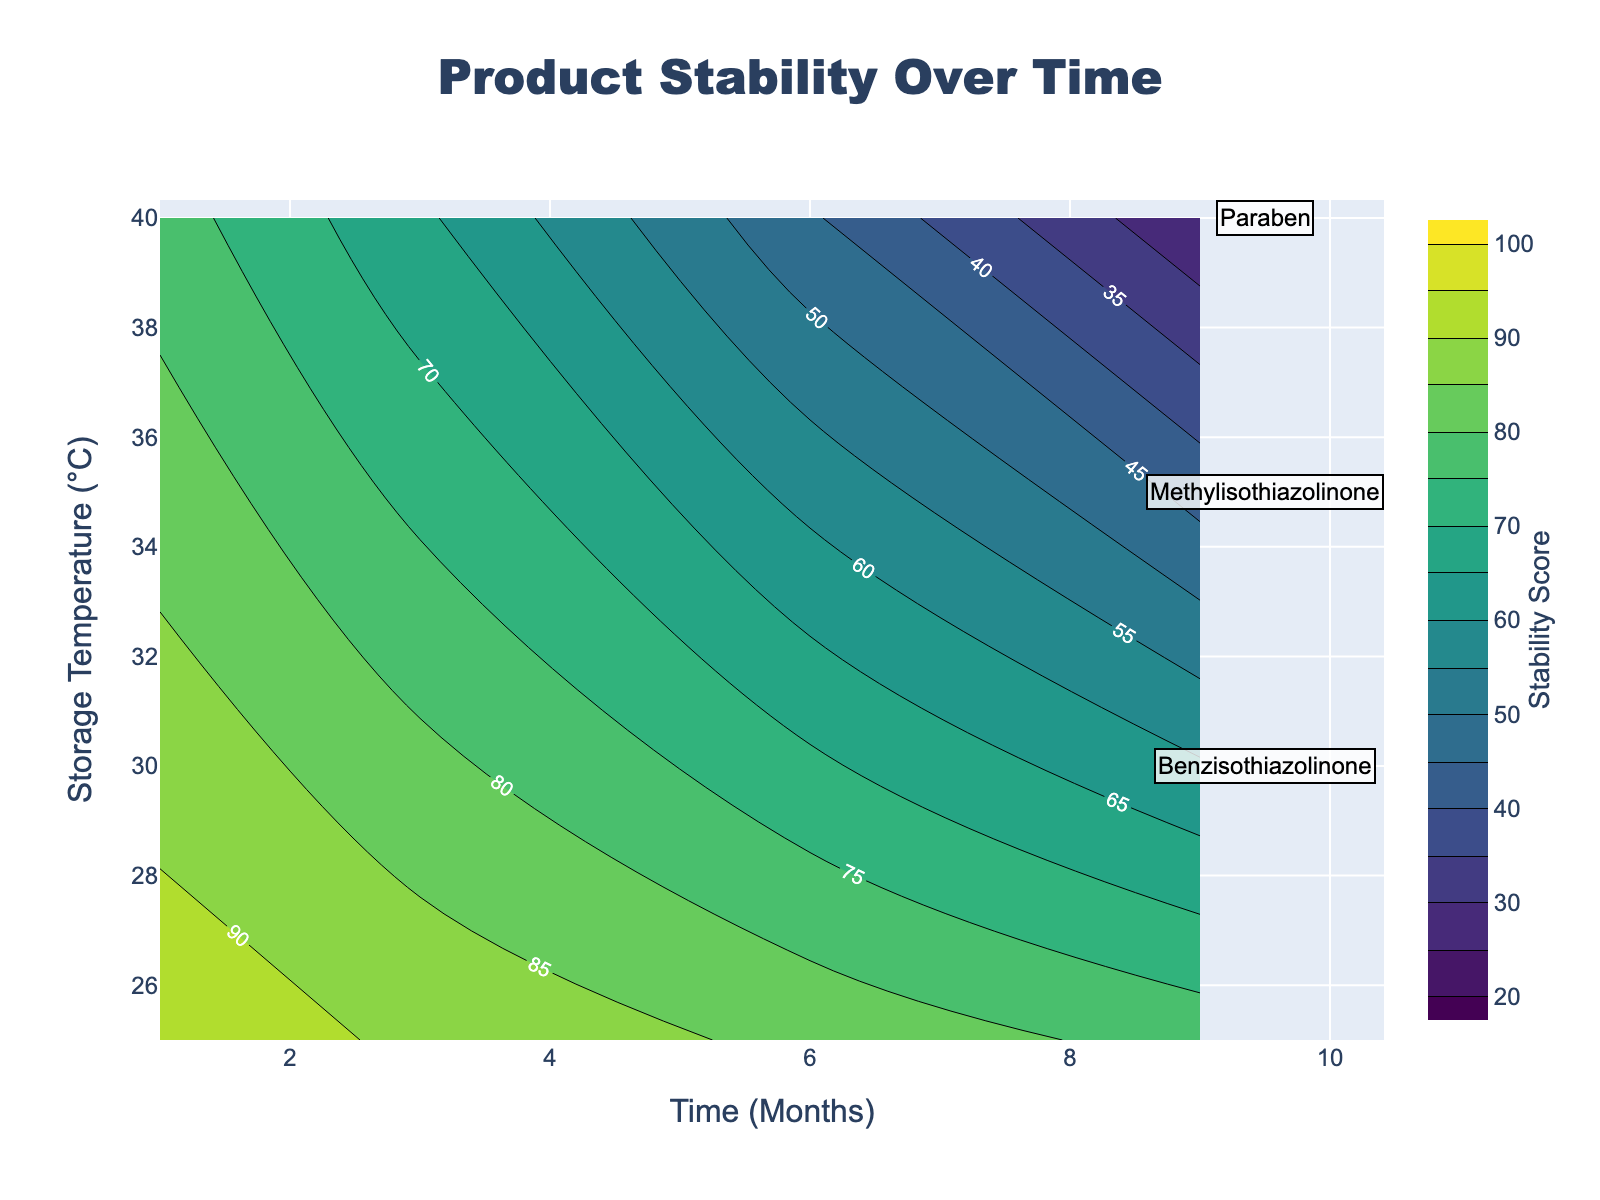What is the title of the figure? The title of the plot is usually placed at the top center. In this case, it's "Product Stability Over Time," as stated in the layout of the plot.
Answer: Product Stability Over Time Which axis represents the storage temperature? By looking at the axis titles, the y-axis denotes the storage temperature, labeled as “Storage Temperature (°C)”.
Answer: Storage Temperature (°C) What color represents the highest stability scores on the contour plot? In the 'Viridis' colorscale, higher stability scores are usually represented by colors towards the yellow/green end, while lower stability scores are towards the purple/blue end.
Answer: Yellow/Green How does the stability score of Paraben change over time at 40°C and 60% humidity? At 40°C and 60% humidity, the stability score of Paraben is highest at month 1 (80) and drops to 30 at month 9, showing a general decreasing trend over time.
Answer: Decreases Compare the stability of Methylisothiazolinone and Benzisothiazolinone at 25°C and 40% humidity after 9 months. At 25°C and 40% humidity after 9 months, Methylisothiazolinone has a stability score of 76 while Benzisothiazolinone has a score of 78, with Benzisothiazolinone being slightly more stable.
Answer: Benzisothiazolinone is slightly more stable Which preservative shows the lowest stability score at 40°C and 60% humidity after 6 months? By observing the contour lines and the data, Paraben has the lowest stability score (50) compared to Methylisothiazolinone (45) and Benzisothiazolinone (42) after 6 months at 40°C and 60% humidity.
Answer: Benzisothiazolinone At which temperature and humidity do all preservatives show a decreasing trend in stability over time? Regardless of the preservative, all lines show a decreasing trend over time at both tested storage conditions—25°C & 40% humidity and 40°C & 60% humidity.
Answer: Both conditions (25°C & 40% humidity and 40°C & 60% humidity) 